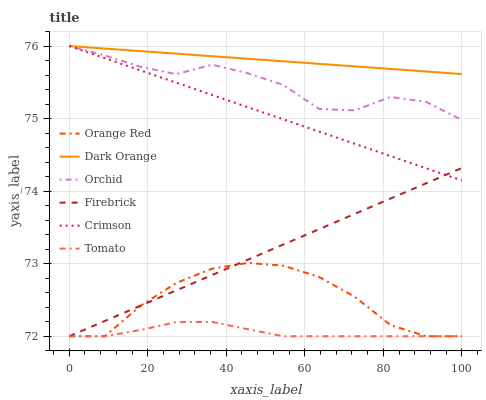Does Tomato have the minimum area under the curve?
Answer yes or no. Yes. Does Dark Orange have the maximum area under the curve?
Answer yes or no. Yes. Does Firebrick have the minimum area under the curve?
Answer yes or no. No. Does Firebrick have the maximum area under the curve?
Answer yes or no. No. Is Firebrick the smoothest?
Answer yes or no. Yes. Is Orchid the roughest?
Answer yes or no. Yes. Is Dark Orange the smoothest?
Answer yes or no. No. Is Dark Orange the roughest?
Answer yes or no. No. Does Dark Orange have the lowest value?
Answer yes or no. No. Does Orchid have the highest value?
Answer yes or no. Yes. Does Firebrick have the highest value?
Answer yes or no. No. Is Tomato less than Orchid?
Answer yes or no. Yes. Is Orchid greater than Orange Red?
Answer yes or no. Yes. Does Tomato intersect Orchid?
Answer yes or no. No. 